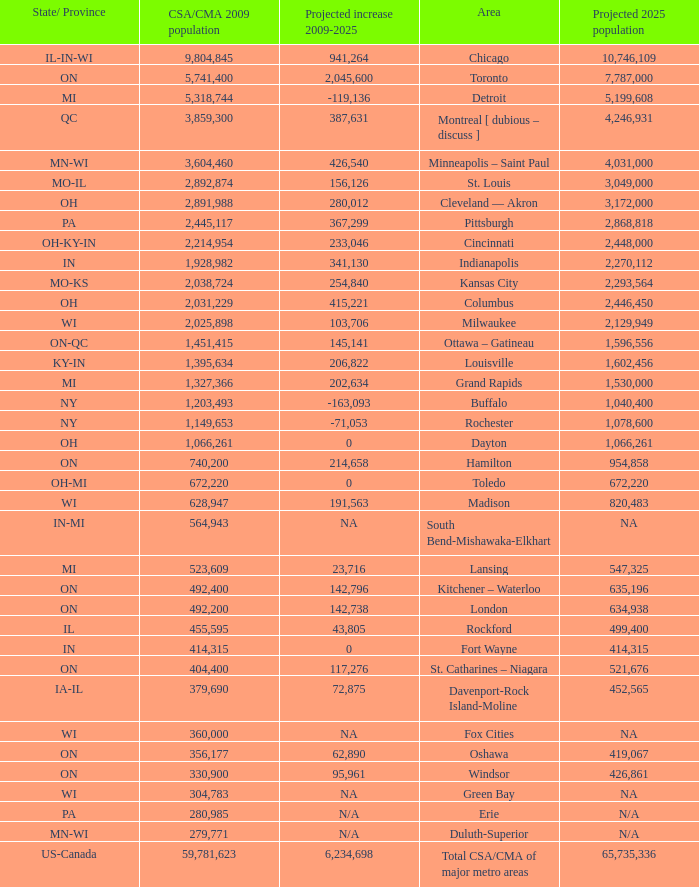What's the CSA/CMA Population in IA-IL? 379690.0. 